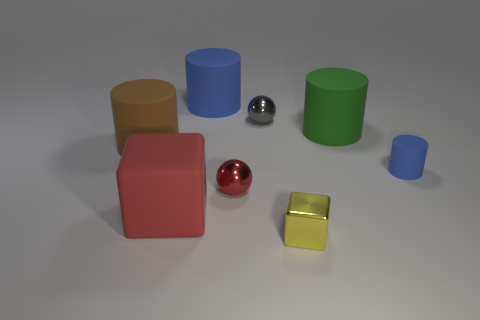What number of things are either shiny objects that are in front of the large green object or tiny shiny spheres?
Make the answer very short. 3. Is the material of the big object on the right side of the red shiny ball the same as the yellow object?
Offer a terse response. No. Do the large blue rubber object and the small matte object have the same shape?
Your answer should be compact. Yes. What number of big rubber cylinders are behind the small ball that is behind the brown matte cylinder?
Keep it short and to the point. 1. There is another small object that is the same shape as the gray thing; what material is it?
Ensure brevity in your answer.  Metal. There is a shiny sphere that is in front of the brown matte cylinder; is it the same color as the rubber block?
Ensure brevity in your answer.  Yes. Does the red block have the same material as the red object that is to the right of the large blue cylinder?
Ensure brevity in your answer.  No. There is a blue object that is right of the tiny red shiny object; what is its shape?
Provide a short and direct response. Cylinder. What number of other things are the same material as the big green thing?
Provide a short and direct response. 4. The green cylinder has what size?
Your answer should be very brief. Large. 